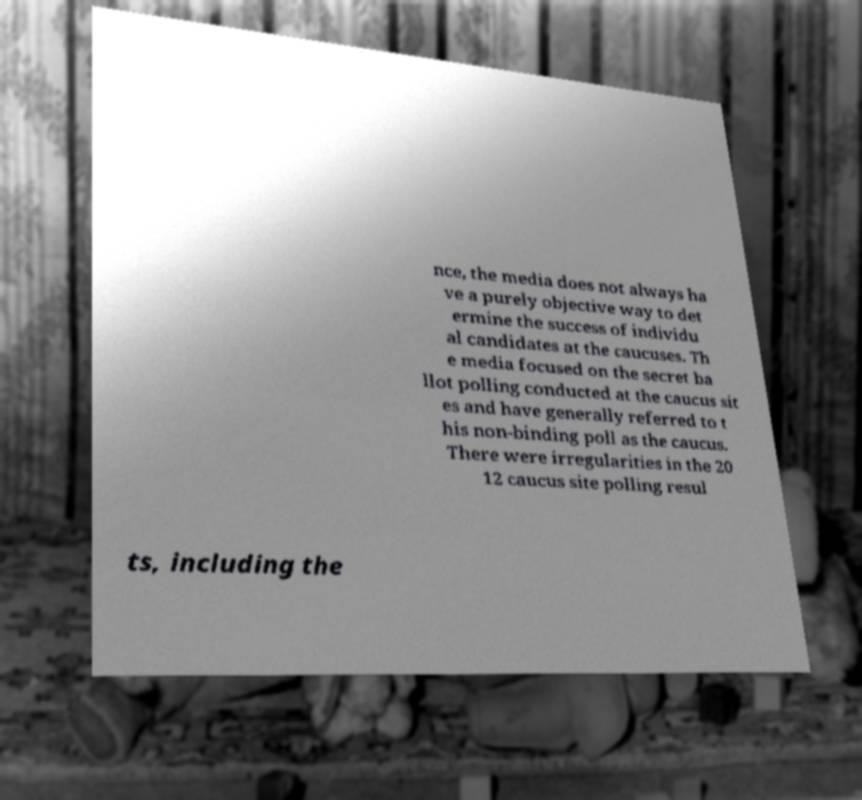I need the written content from this picture converted into text. Can you do that? nce, the media does not always ha ve a purely objective way to det ermine the success of individu al candidates at the caucuses. Th e media focused on the secret ba llot polling conducted at the caucus sit es and have generally referred to t his non-binding poll as the caucus. There were irregularities in the 20 12 caucus site polling resul ts, including the 